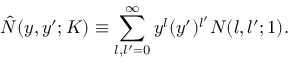<formula> <loc_0><loc_0><loc_500><loc_500>\hat { N } ( y , y ^ { \prime } ; K ) \equiv \sum _ { l , l ^ { \prime } = 0 } ^ { \infty } y ^ { l } ( y ^ { \prime } ) ^ { l ^ { \prime } } N ( l , l ^ { \prime } ; 1 ) .</formula> 